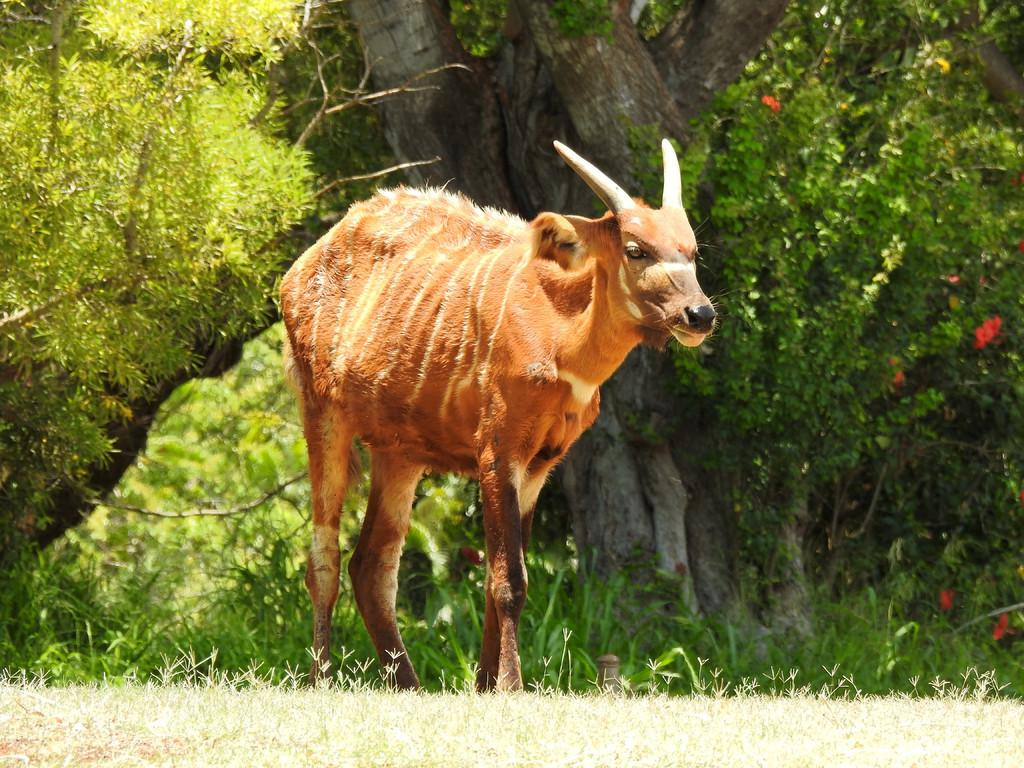What type of animal is in the image? There is a brown cow in the image. What can be seen in the distance behind the cow? Trees are visible in the background of the image. What type of vegetation is at the bottom of the image? There is grass at the bottom of the image. What show is the cow performing in the image? There is no show or performance depicted in the image; it simply shows a brown cow in a natural setting. 